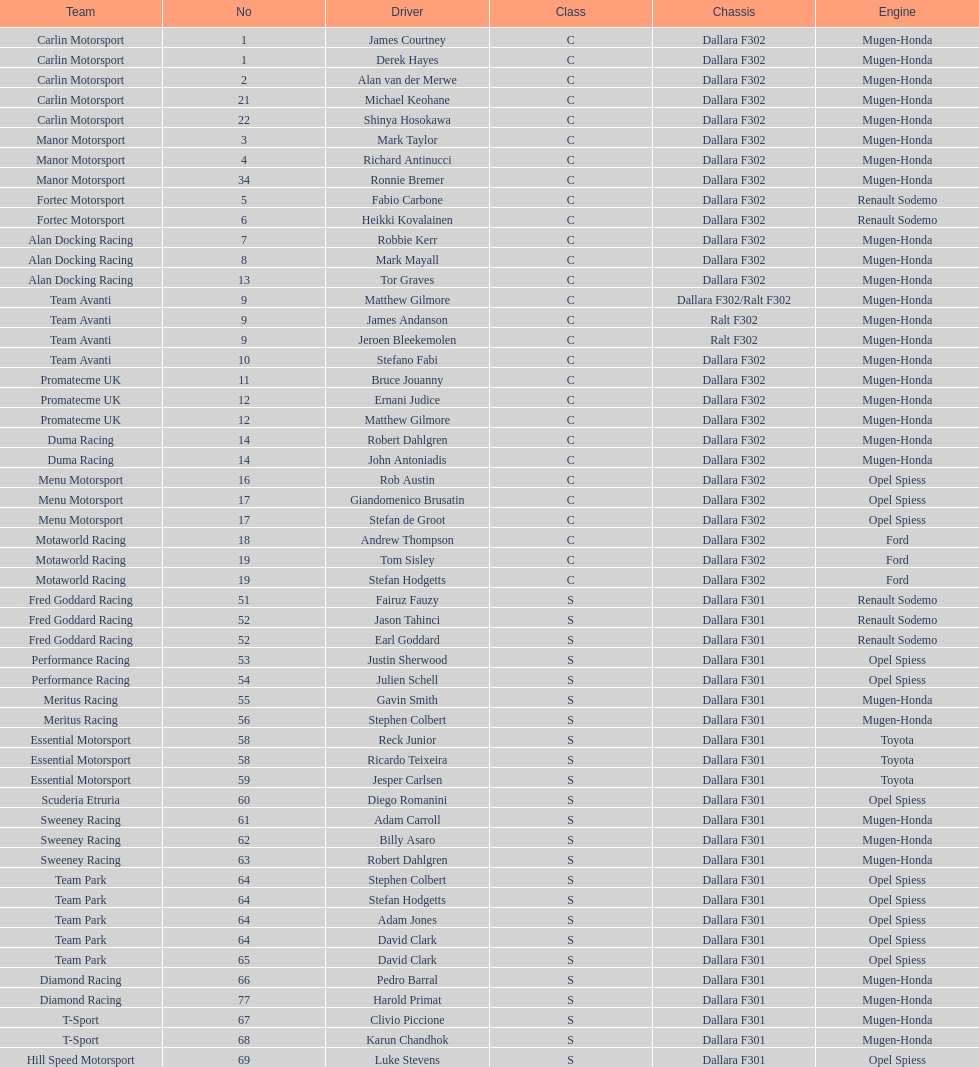Which engine was used the most by teams this season? Mugen-Honda. 